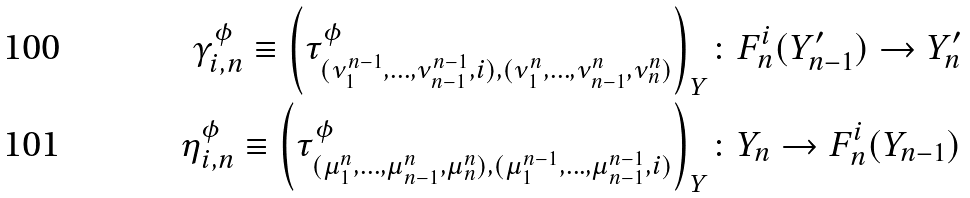Convert formula to latex. <formula><loc_0><loc_0><loc_500><loc_500>\gamma ^ { \phi } _ { i , n } \equiv \left ( \tau ^ { \phi } _ { ( \nu ^ { n - 1 } _ { 1 } , \dots , \nu ^ { n - 1 } _ { n - 1 } , i ) , ( \nu ^ { n } _ { 1 } , \dots , \nu ^ { n } _ { n - 1 } , \nu ^ { n } _ { n } ) } \right ) _ { Y } & \colon F _ { n } ^ { i } ( Y ^ { \prime } _ { n - 1 } ) \rightarrow Y _ { n } ^ { \prime } \\ \eta ^ { \phi } _ { i , n } \equiv \left ( \tau ^ { \phi } _ { ( \mu ^ { n } _ { 1 } , \dots , \mu ^ { n } _ { n - 1 } , \mu ^ { n } _ { n } ) , ( \mu ^ { n - 1 } _ { 1 } , \dots , \mu ^ { n - 1 } _ { n - 1 } , i ) } \right ) _ { Y } & \colon Y _ { n } \rightarrow F _ { n } ^ { i } ( Y _ { n - 1 } )</formula> 